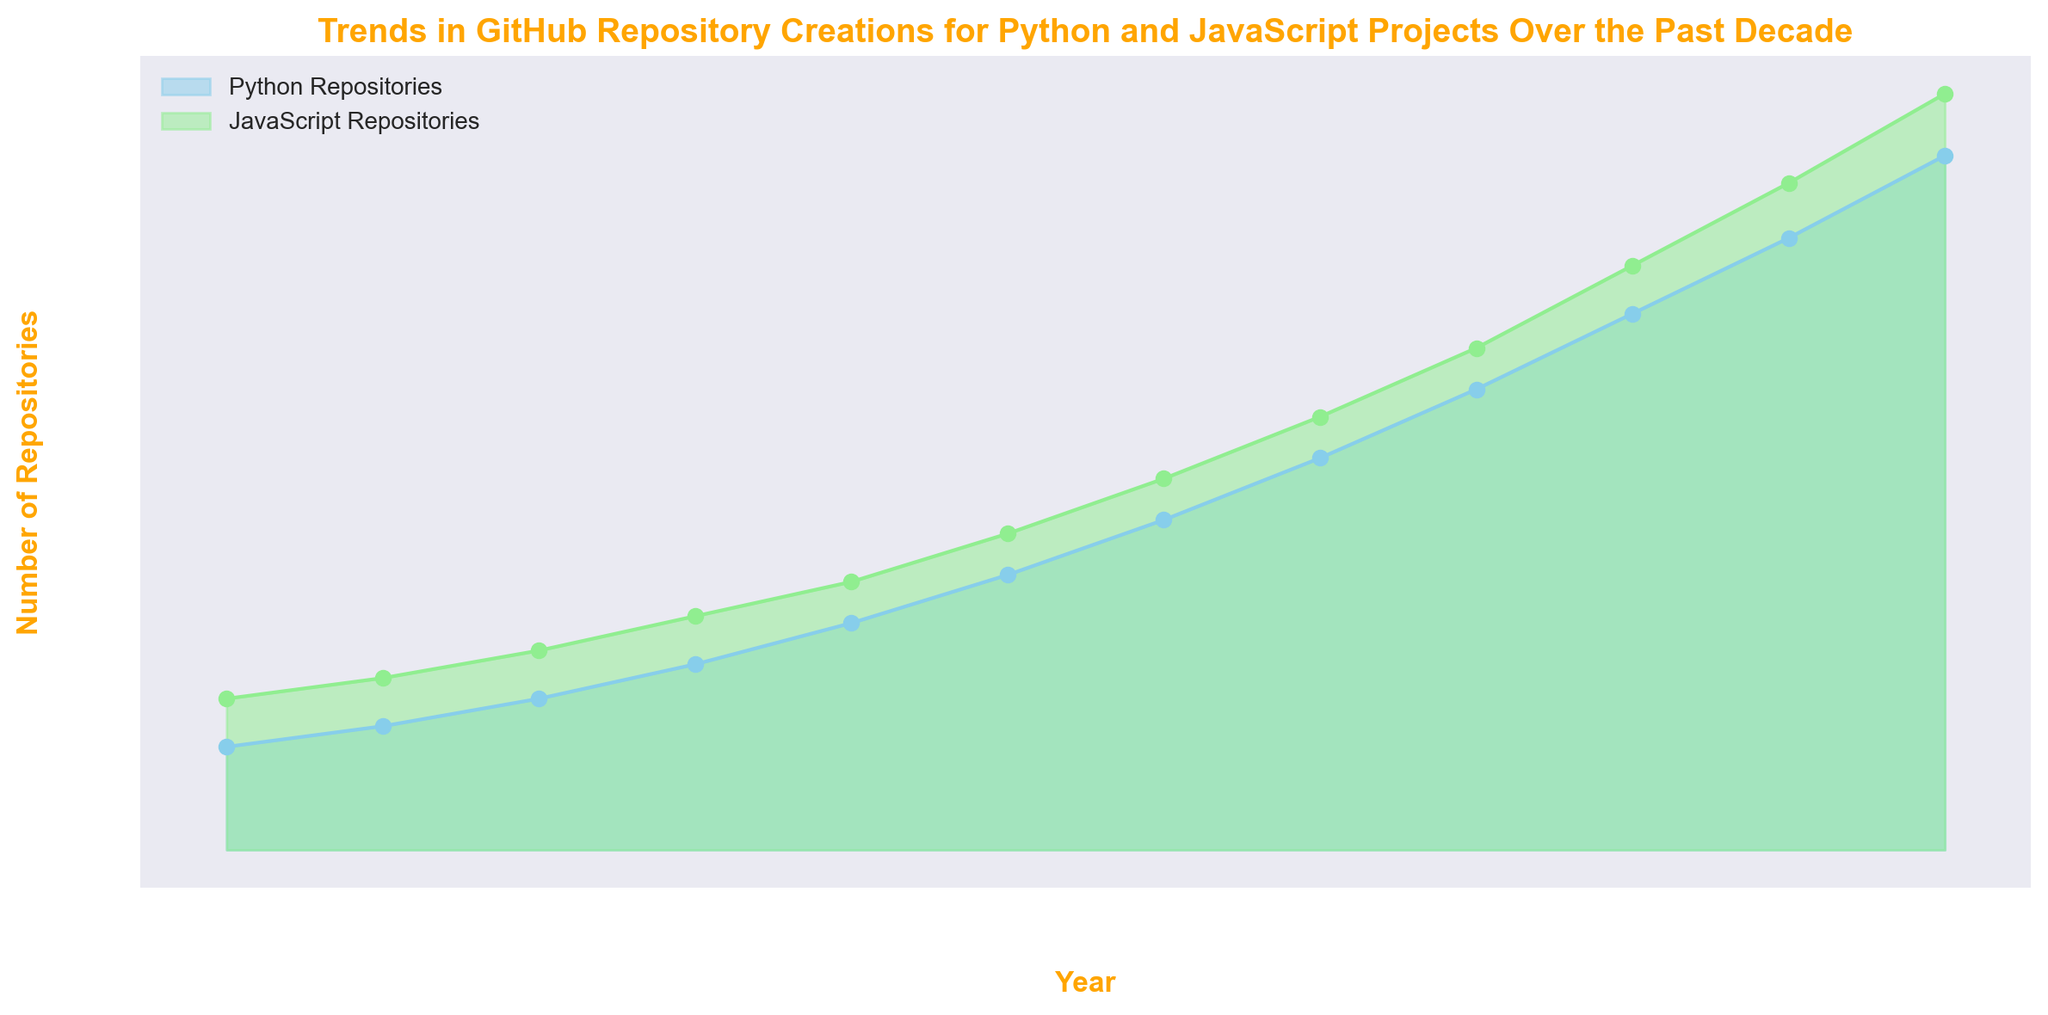What's the total number of Python repositories created by 2021? To find the total number of Python repositories created by 2021, sum the values for the years 2012 to 2021. (1500 + 1800 + 2200 + 2700 + 3300 + 4000 + 4800 + 5700 + 6700 + 7800) = 38400 Python repositories.
Answer: 38400 In which year did the number of JavaScript repositories first exceed 5000? Check the data for JavaScript repositories over the years and look for the first year in which the number surpasses 5000. This occurs in 2018 with 5400 JavaScript repositories.
Answer: 2018 Which year experienced the highest increase in Python repositories compared to the previous year? Calculate the year-over-year increase for Python repositories by subtracting the previous year's count from the current year's count. The highest increase is from 2019 to 2020 with 6700 - 5700 = 1000 new repositories.
Answer: 2020 Did both Python and JavaScript repositories increase every year? Check if both Python and JavaScript repositories increase every year by scanning the values for each year. Both trends show a consistent year-over-year increase.
Answer: Yes Which year saw the closest number of repositories between Python and JavaScript? Calculate the difference in the number of repositories between Python and JavaScript for each year, and identify the year with the smallest difference. For 2012: abs(1500 - 2200) = 700, For the remaining years: 2013: 700, 2014: 700, ..., 2023: 900. The smallest difference is in 2012 and 2015 with 700.
Answer: 2012, 2015 What is the approximate average number of JavaScript repositories created per year from 2012 to 2023? Sum the number of JavaScript repositories from 2012 to 2023 and divide by the number of years. (2200 + 2500 + 2900 + 3400 + 3900 + 4600 + 5400 + 6300 + 7300 + 8500 + 9700 + 11000) / 12 = 5725.
Answer: 5725 In which year did the total number of repositories (Python + JavaScript) first exceed 10,000? Sum the repositories for Python and JavaScript for each year until the total exceeds 10,000. 2018: 4800 + 5400 = 10200.
Answer: 2018 By how much did the number of JavaScript repositories increase between 2015 and 2023? Subtract the number of JavaScript repositories in 2015 from the number in 2023. 11000 - 3400 = 7600.
Answer: 7600 How many more Python repositories were created in 2023 compared to 2012? Subtract the number of Python repositories in 2012 from the number in 2023. 10100 - 1500 = 8600.
Answer: 8600 